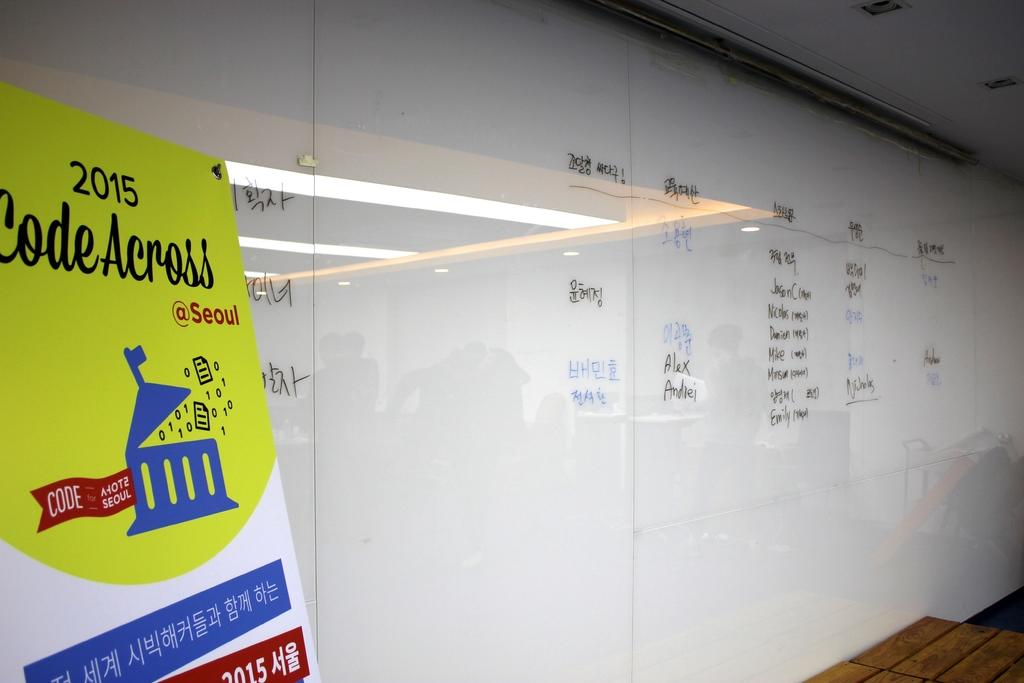<image>
Offer a succinct explanation of the picture presented. The year printed above the words "Code Across" on the yellow sign is 2015. 